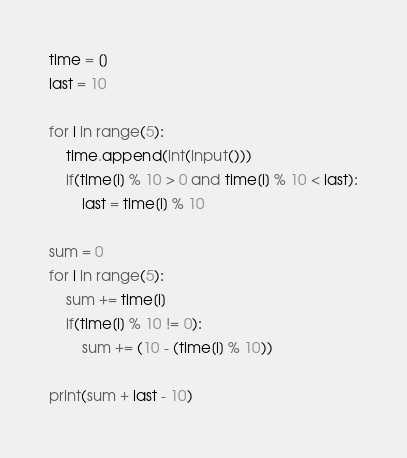Convert code to text. <code><loc_0><loc_0><loc_500><loc_500><_Python_>time = []
last = 10

for i in range(5):
    time.append(int(input()))
    if(time[i] % 10 > 0 and time[i] % 10 < last):
        last = time[i] % 10

sum = 0
for i in range(5):
    sum += time[i]
    if(time[i] % 10 != 0):
        sum += (10 - (time[i] % 10))

print(sum + last - 10)</code> 